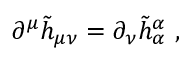<formula> <loc_0><loc_0><loc_500><loc_500>\partial ^ { \mu } \tilde { h } _ { \mu \nu } = \partial _ { \nu } \tilde { h } _ { \alpha } ^ { \alpha } \ ,</formula> 